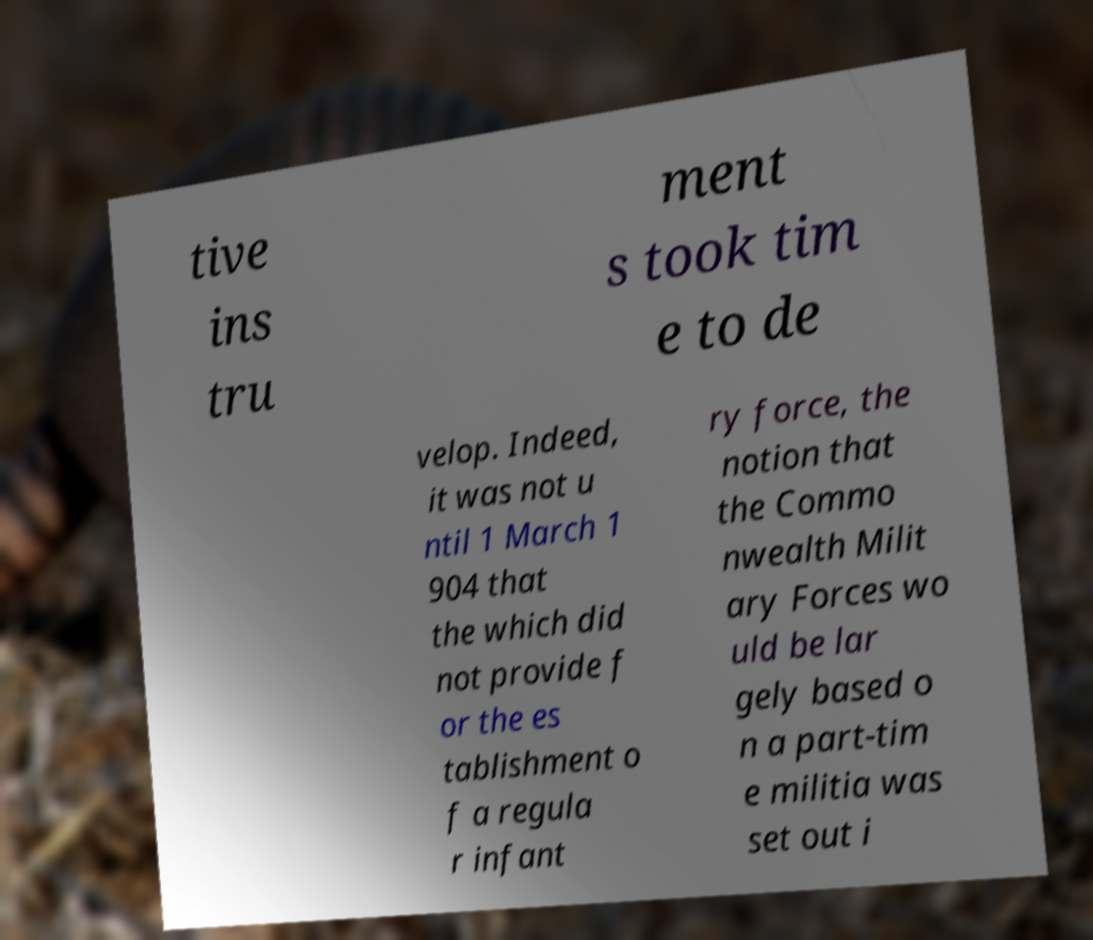Please read and relay the text visible in this image. What does it say? tive ins tru ment s took tim e to de velop. Indeed, it was not u ntil 1 March 1 904 that the which did not provide f or the es tablishment o f a regula r infant ry force, the notion that the Commo nwealth Milit ary Forces wo uld be lar gely based o n a part-tim e militia was set out i 